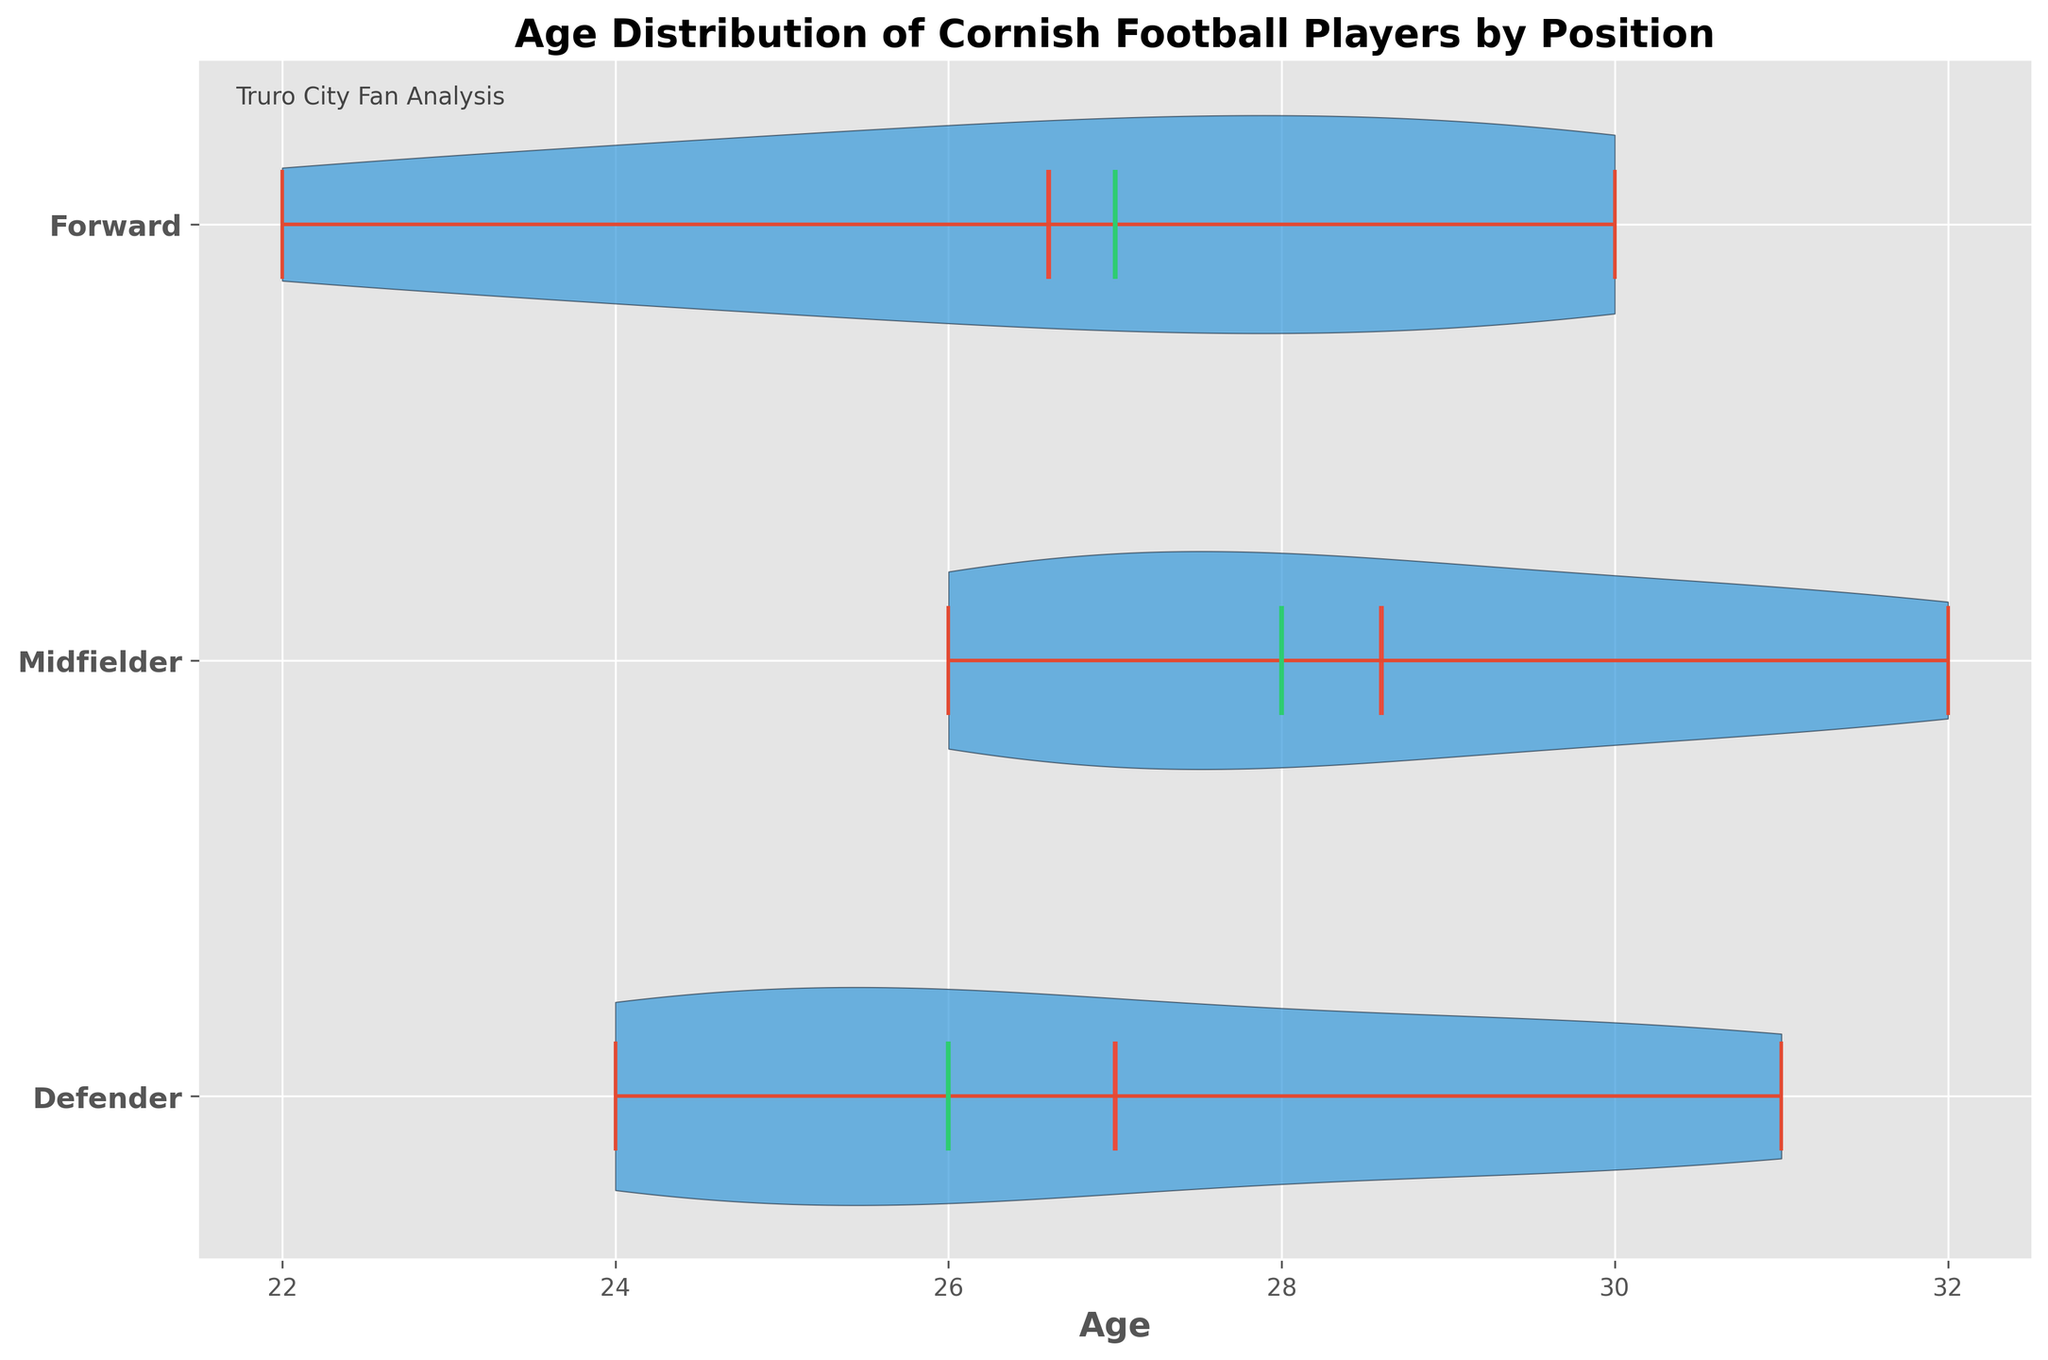What's the title of the chart? The title of the chart is usually found at the top and in this case, it's displayed prominently.
Answer: Age Distribution of Cornish Football Players by Position Which position group has the highest median age? The horizontal violin chart shows the median with a distinct line through the middle of the distribution; the group with the highest median value can be identified by the position of this line.
Answer: Midfielders What color represents the mean age on the chart? In the chart, specific attributes like color highlight different statistical measures. By looking at which color represents the mean (often indicated in the legend or label), we see it is denoted by a specific color.
Answer: Red How many positions are compared in the chart? The comparison can be seen through the number of distinct violins on the y-axis, which represent different player groups.
Answer: 3 Which position has the widest age distribution? The width of the violin at different points indicates the distribution spread. The position with the overall widest spread at any age indicates the widest distribution.
Answer: Forwards Which age group shows the most variation for defenders, midfielders, and forwards respectively? The width of the violin plot at different points can be observed to find where each group's distribution is most spread out. Each group's widest point signifies the most variation.
Answer: Defenders: 29-31, Midfielders: 27-30, Forwards: 25-30 What is the youngest age displayed for forwards? The lowest point on the age axis of the forward’s violin plot represents the youngest age.
Answer: 22 Are the ages of midfielders more evenly distributed than those of defenders? By comparing both the central concentration and spread of the violins for midfielders and defenders, an even distribution can be identified by less elongation and a uniform spread of the violin plot.
Answer: Yes What's the difference between the median age for defenders and forwards? Identify the median ages for both defenders and forwards from the horizontal lines through the violins and subtract the lower from the higher.
Answer: 2 years Which group has the highest concentration of players around the age of 29? Concentration is visible as the thickest part of the violin plot around the specified age. Look at the age of 29 across all positions and note which violin is widest at that point.
Answer: Defenders 